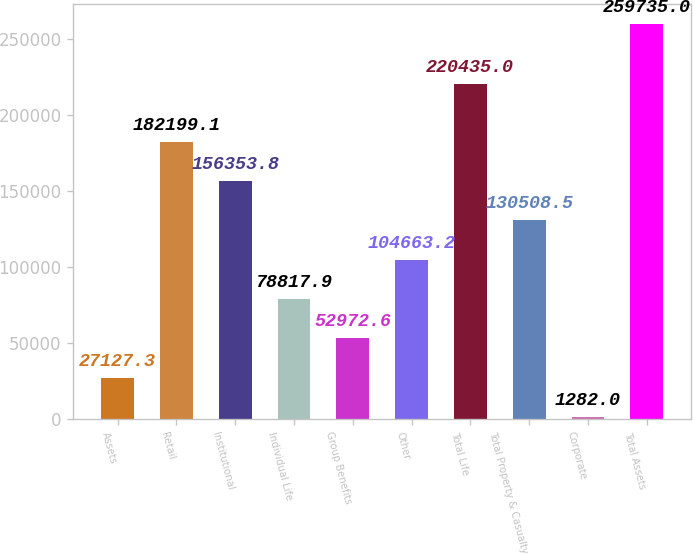Convert chart to OTSL. <chart><loc_0><loc_0><loc_500><loc_500><bar_chart><fcel>Assets<fcel>Retail<fcel>Institutional<fcel>Individual Life<fcel>Group Benefits<fcel>Other<fcel>Total Life<fcel>Total Property & Casualty<fcel>Corporate<fcel>Total Assets<nl><fcel>27127.3<fcel>182199<fcel>156354<fcel>78817.9<fcel>52972.6<fcel>104663<fcel>220435<fcel>130508<fcel>1282<fcel>259735<nl></chart> 